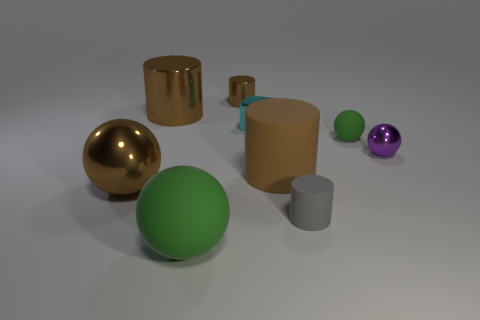Are there more large matte balls than big gray matte spheres?
Provide a succinct answer. Yes. Is the color of the metallic ball in front of the brown rubber object the same as the cylinder on the left side of the big green rubber sphere?
Give a very brief answer. Yes. There is a tiny metallic ball that is right of the gray cylinder; is there a large brown rubber thing behind it?
Your response must be concise. No. Are there fewer tiny green things right of the small shiny cube than large matte things that are behind the large brown rubber cylinder?
Your response must be concise. No. Do the cylinder in front of the brown rubber thing and the green thing to the right of the brown rubber object have the same material?
Offer a terse response. Yes. How many big objects are either purple balls or gray objects?
Your answer should be compact. 0. There is a brown object that is made of the same material as the tiny green thing; what is its shape?
Give a very brief answer. Cylinder. Is the number of small gray objects behind the big green rubber object less than the number of metallic balls?
Offer a terse response. Yes. Is the shape of the gray matte object the same as the brown matte thing?
Your response must be concise. Yes. How many metal objects are tiny gray cylinders or small cubes?
Your answer should be very brief. 1. 